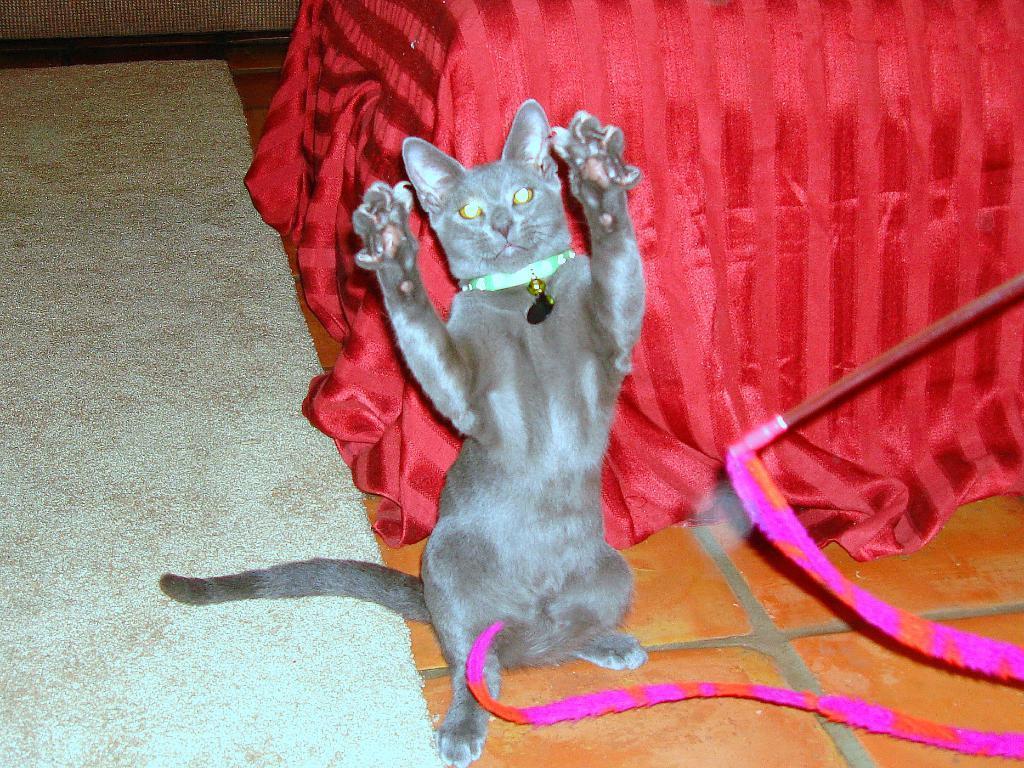Please provide a concise description of this image. In this image I can see the brown colored floor, the floor mat and a cat which is brown and ash in color. I can see a stick and a pink and orange colored cloth to the stick. I can see a red colored cloth behind the cat. 